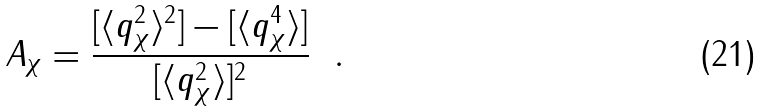Convert formula to latex. <formula><loc_0><loc_0><loc_500><loc_500>A _ { \chi } = \frac { [ \langle q _ { \chi } ^ { 2 } \rangle ^ { 2 } ] - [ \langle q _ { \chi } ^ { 4 } \rangle ] } { [ \langle q _ { \chi } ^ { 2 } \rangle ] ^ { 2 } } \ \ .</formula> 